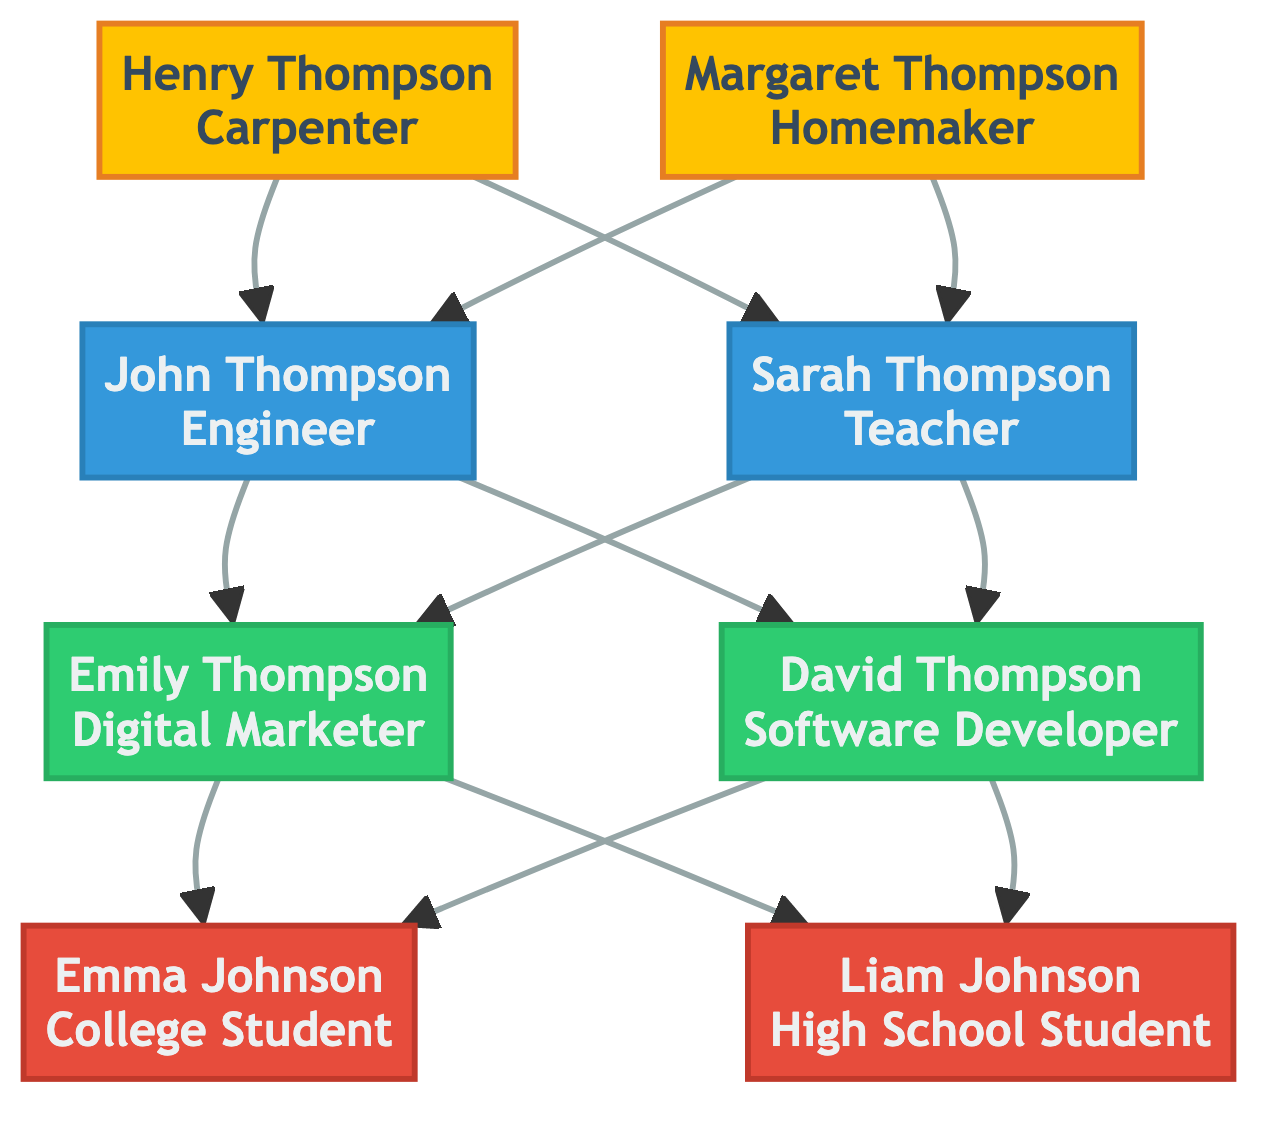What is the profession of John Thompson? John Thompson is identified in the diagram as an engineer. By examining his node directly, we can confirm his profession.
Answer: Engineer How many grandchildren does Henry Thompson have? To find the number of grandchildren, we look at the grandchildren nodes connected to Henry Thompson. There are two grandchildren: Emma Johnson and Liam Johnson.
Answer: 2 Who is David Thompson’s parent? David Thompson is linked to his parents, John and Sarah Thompson. To determine his parent, we can trace the connection upwards to find that John Thompson is his father.
Answer: John Thompson What influence did Margaret Thompson have regarding remote work? Margaret Thompson's influence is described in her node, indicating that her organizational skills served as a model for balancing work and personal life. This directly correlates with remote work, highlighting her impact.
Answer: Organizational skills Which grandchild assists with tech setup for remote communication? The node for Liam Johnson specifically states that he helps his grandparents with tech setup for remote communication platforms. This directly answers the query regarding which grandchild has this involvement.
Answer: Liam Johnson What job did Sarah Thompson start to supplement family income? The diagram indicates that Sarah Thompson started tutoring online to supplement family income. By reviewing her node’s description, we can ascertain her job.
Answer: Tutoring online How did Emily Thompson influence her family? Emily Thompson's influence is described in her node as inspiring her parents and peers to consider remote work due to her positive experience. We can gather that her actions opened discussions about remote work benefits.
Answer: Inspired family Who are the grandparents of Emma Johnson? By moving up the diagram to Emma Johnson's node, we see that her grandparents are Henry and Margaret Thompson. This direct connection allows us to easily identify them.
Answer: Henry and Margaret Thompson What did John Thompson do to open discussions about remote work? The diagram states that John Thompson transitioned to remote work due to job relocation challenges and for better work-life balance. His experience laid the groundwork for discussions on remote work within the family.
Answer: Transitioned to remote work 